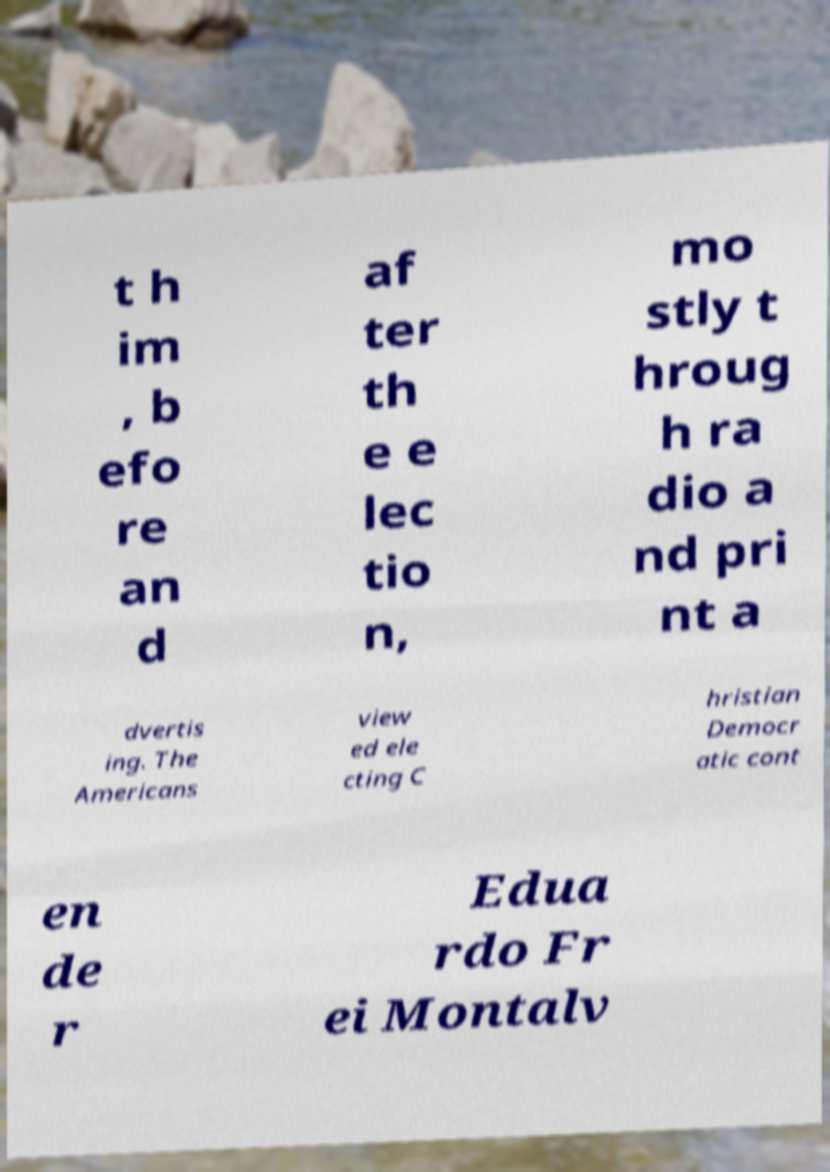For documentation purposes, I need the text within this image transcribed. Could you provide that? t h im , b efo re an d af ter th e e lec tio n, mo stly t hroug h ra dio a nd pri nt a dvertis ing. The Americans view ed ele cting C hristian Democr atic cont en de r Edua rdo Fr ei Montalv 